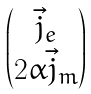<formula> <loc_0><loc_0><loc_500><loc_500>\begin{pmatrix} \vec { j } _ { e } \\ 2 \alpha \vec { j } _ { m } \end{pmatrix}</formula> 